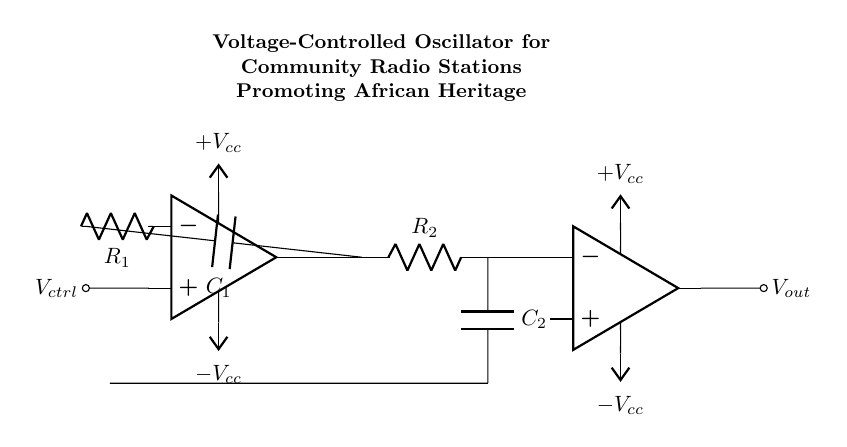What is the control voltage input in this circuit? The control voltage input is connected to the non-inverting input of the operational amplifier, indicated by the node labeled as V_ctrl.
Answer: V_ctrl What is the role of C1 in this oscillator? C1 is part of the feedback network and controls the frequency of oscillation together with R1, affecting the timing characteristics.
Answer: Frequency control How many resistors are present in this circuit? There are two resistors in the diagram, labeled as R1 and R2.
Answer: 2 Which component acts as the output buffer? The component functioning as the output buffer is the operational amplifier shown on the right-hand side of the circuit connected to node tune.
Answer: Operational amplifier Why is a voltage-controlled oscillator used in community radio stations? A voltage-controlled oscillator allows for frequency modulation, enabling seamless adjustments of the transmitted frequency, which is essential for community radio broadcasts.
Answer: Frequency modulation What is the purpose of the Vcc connections? The Vcc connections provide the necessary power supply to both operational amplifiers in the circuit, allowing them to function correctly.
Answer: Power supply What is the type of oscillator represented in this circuit? The circuit is represented as a voltage-controlled oscillator, as indicated by the presence of control voltage influencing its frequency output.
Answer: Voltage-controlled oscillator 